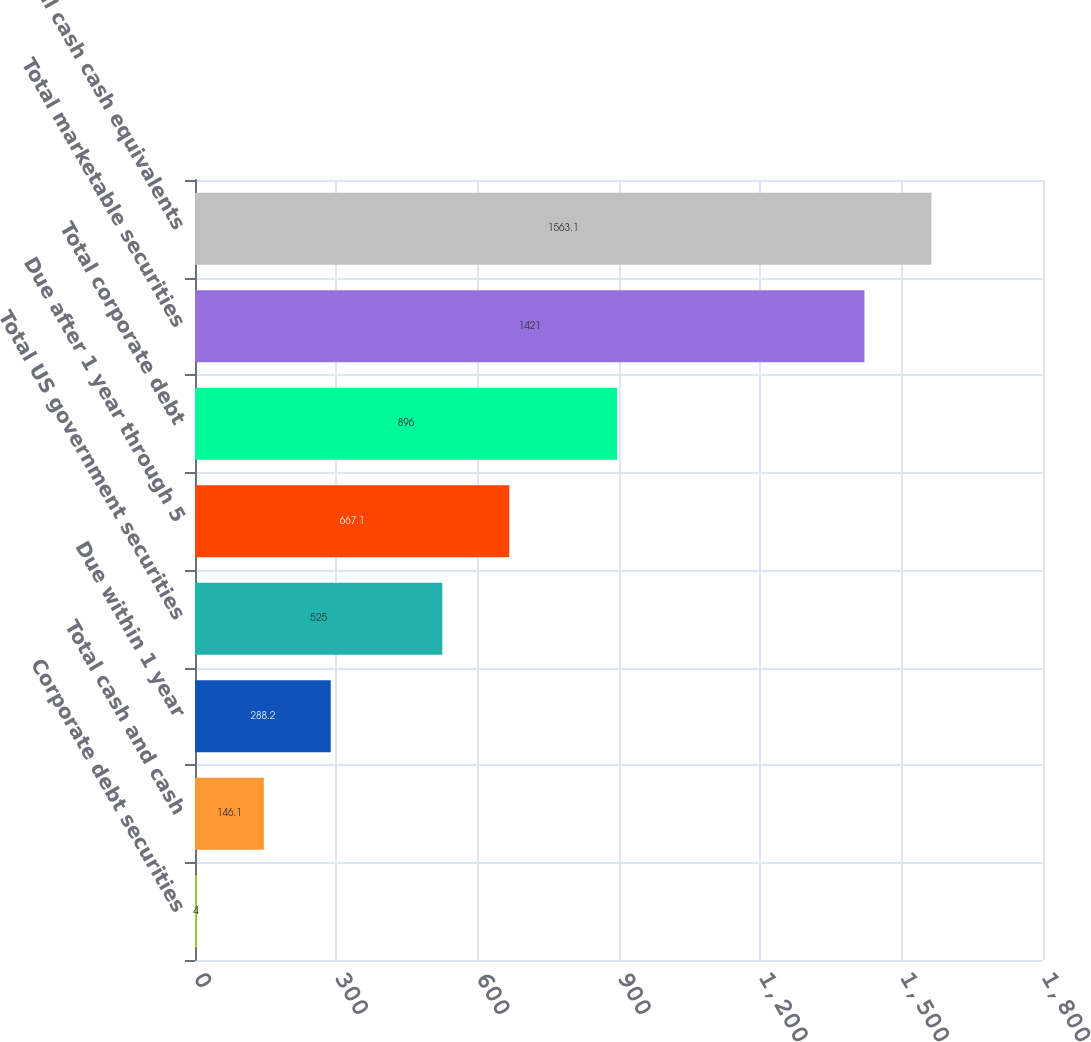Convert chart. <chart><loc_0><loc_0><loc_500><loc_500><bar_chart><fcel>Corporate debt securities<fcel>Total cash and cash<fcel>Due within 1 year<fcel>Total US government securities<fcel>Due after 1 year through 5<fcel>Total corporate debt<fcel>Total marketable securities<fcel>Total cash cash equivalents<nl><fcel>4<fcel>146.1<fcel>288.2<fcel>525<fcel>667.1<fcel>896<fcel>1421<fcel>1563.1<nl></chart> 